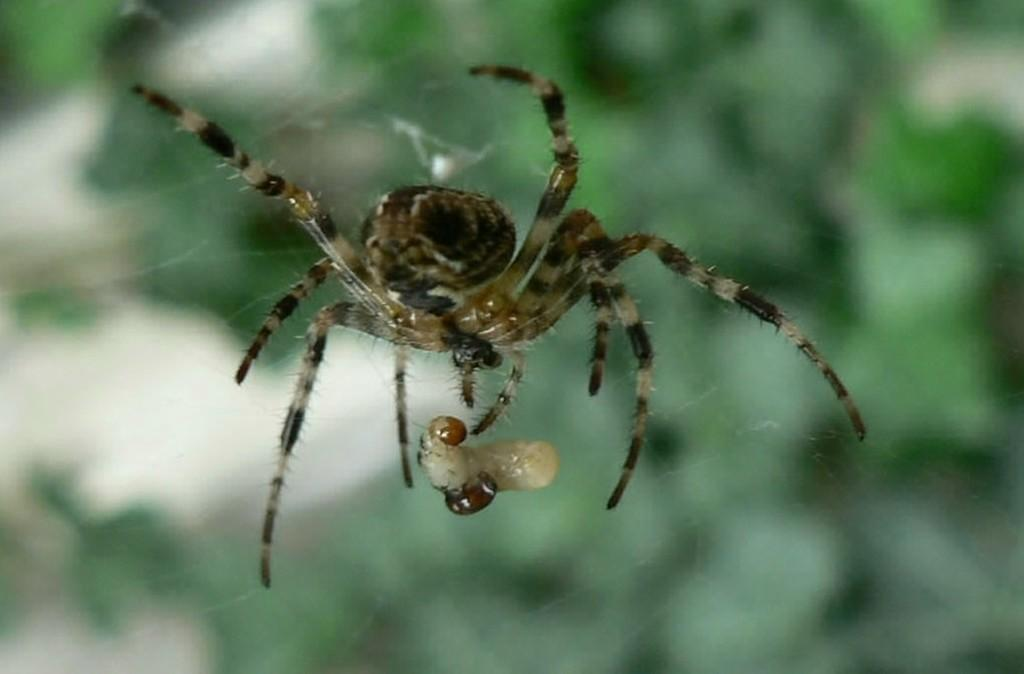What is the main subject of the image? There is a spider in the image. Where is the spider located in the image? The spider is in the center of the image. What is associated with the spider in the image? There is a spider web in the image. Can you describe the background of the image? The background of the image is blurry. What type of book is the spider reading in the image? There is no book present in the image, as it features a spider and a spider web. 